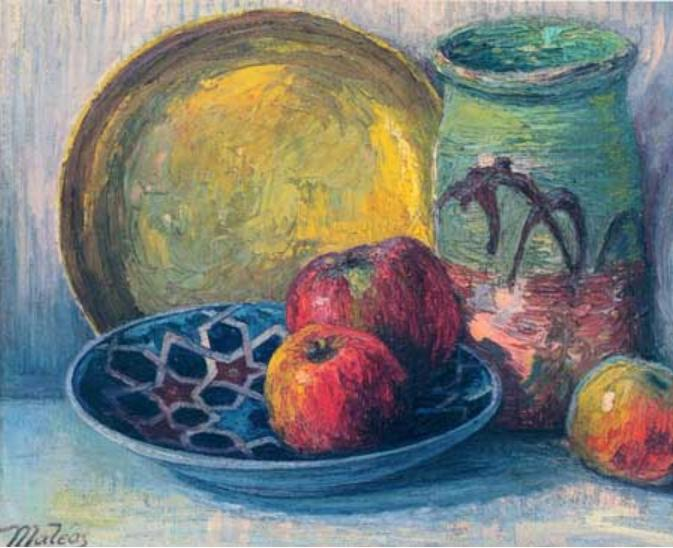If this painting were a memory, whose memory might it be and what story does it tell? If this painting were a memory, it might belong to someone reflecting on moments spent in a rustic, sunlit kitchen. Perhaps it is the memory of an artist who has long passed, whose mornings were filled with simple yet delightful routines. The story it tells is one of quiet, unspoken contentment—of a person who found beauty in the mundane. Each object, carefully placed, is a reminder of the tactile and sensory experiences that defined those peaceful days: the tangy crispness of apples, the smooth coolness of the ceramic bowl, the earthy texture of the vase, and the cheerful glow of the yellow plate. 